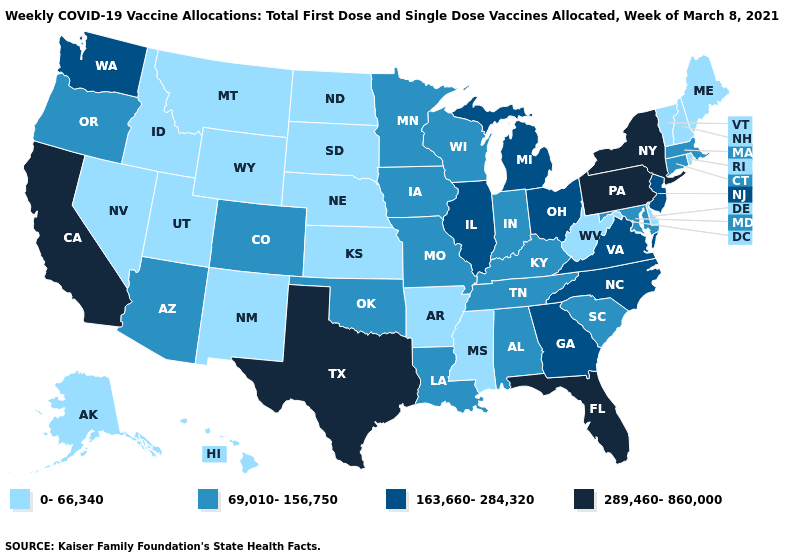What is the value of Arkansas?
Give a very brief answer. 0-66,340. What is the value of Florida?
Short answer required. 289,460-860,000. Among the states that border Connecticut , which have the highest value?
Write a very short answer. New York. What is the value of California?
Give a very brief answer. 289,460-860,000. Name the states that have a value in the range 289,460-860,000?
Keep it brief. California, Florida, New York, Pennsylvania, Texas. Does New York have the highest value in the USA?
Write a very short answer. Yes. Name the states that have a value in the range 163,660-284,320?
Concise answer only. Georgia, Illinois, Michigan, New Jersey, North Carolina, Ohio, Virginia, Washington. What is the highest value in states that border Kansas?
Short answer required. 69,010-156,750. Among the states that border Texas , which have the lowest value?
Keep it brief. Arkansas, New Mexico. Which states hav the highest value in the MidWest?
Concise answer only. Illinois, Michigan, Ohio. What is the value of North Carolina?
Short answer required. 163,660-284,320. Name the states that have a value in the range 69,010-156,750?
Be succinct. Alabama, Arizona, Colorado, Connecticut, Indiana, Iowa, Kentucky, Louisiana, Maryland, Massachusetts, Minnesota, Missouri, Oklahoma, Oregon, South Carolina, Tennessee, Wisconsin. What is the value of South Carolina?
Quick response, please. 69,010-156,750. Among the states that border Alabama , which have the highest value?
Write a very short answer. Florida. Name the states that have a value in the range 289,460-860,000?
Answer briefly. California, Florida, New York, Pennsylvania, Texas. 